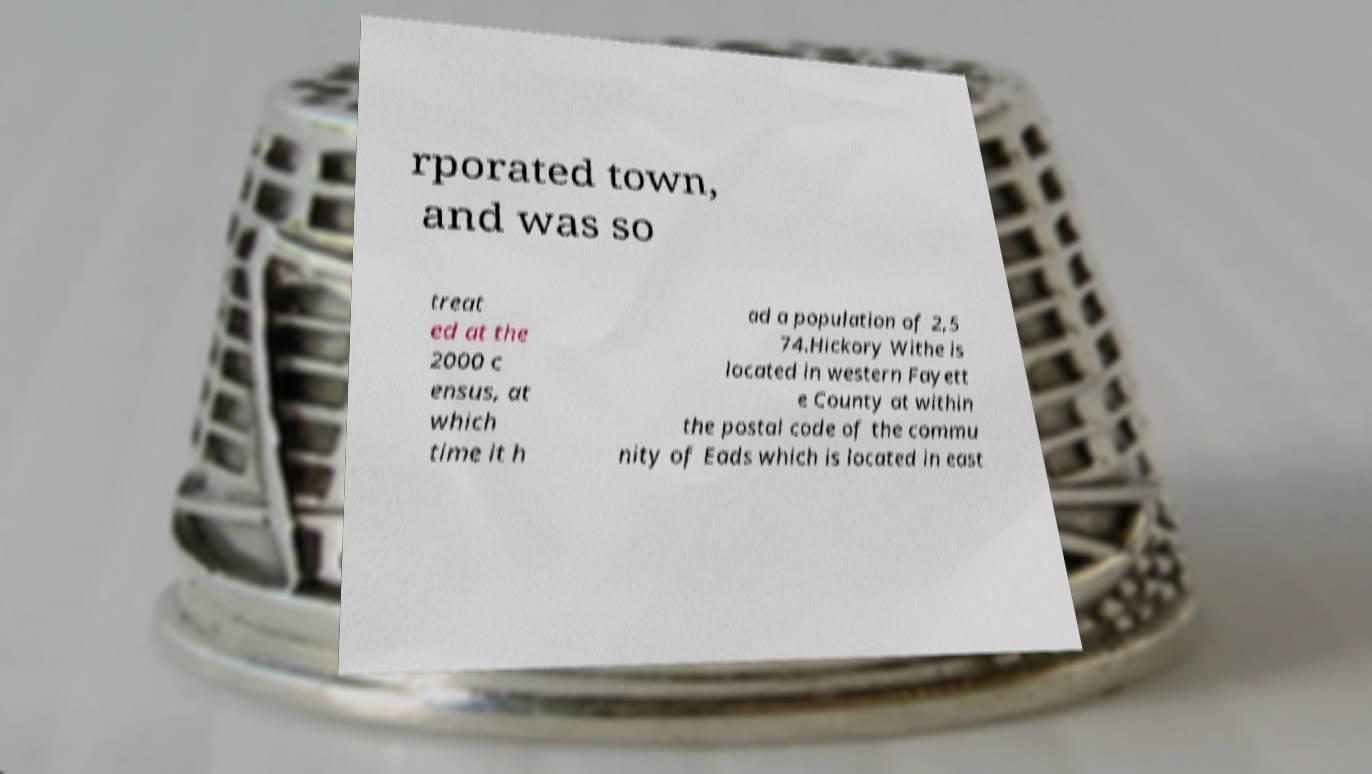I need the written content from this picture converted into text. Can you do that? rporated town, and was so treat ed at the 2000 c ensus, at which time it h ad a population of 2,5 74.Hickory Withe is located in western Fayett e County at within the postal code of the commu nity of Eads which is located in east 